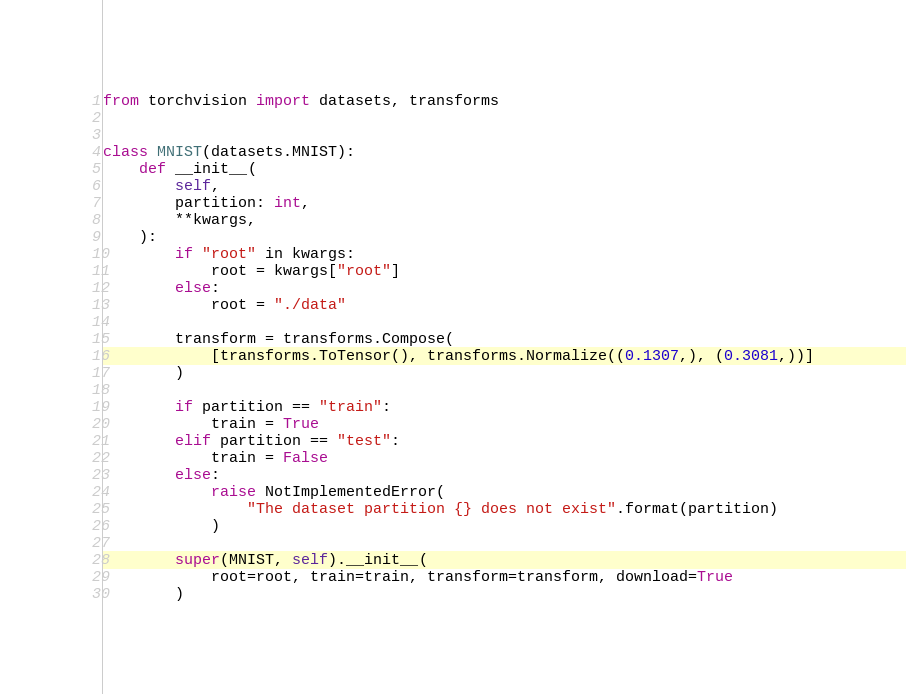Convert code to text. <code><loc_0><loc_0><loc_500><loc_500><_Python_>from torchvision import datasets, transforms


class MNIST(datasets.MNIST):
    def __init__(
        self,
        partition: int,
        **kwargs,
    ):
        if "root" in kwargs:
            root = kwargs["root"]
        else:
            root = "./data"

        transform = transforms.Compose(
            [transforms.ToTensor(), transforms.Normalize((0.1307,), (0.3081,))]
        )

        if partition == "train":
            train = True
        elif partition == "test":
            train = False
        else:
            raise NotImplementedError(
                "The dataset partition {} does not exist".format(partition)
            )

        super(MNIST, self).__init__(
            root=root, train=train, transform=transform, download=True
        )
</code> 